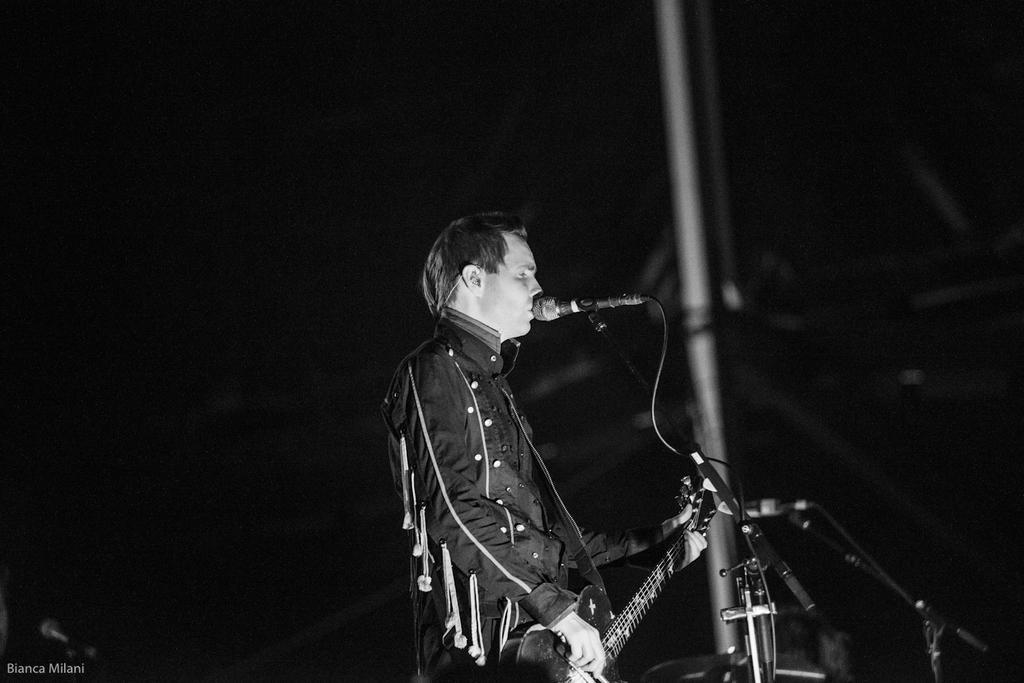In one or two sentences, can you explain what this image depicts? The person wearing black dress is playing guitar and singing in front of a mic. 